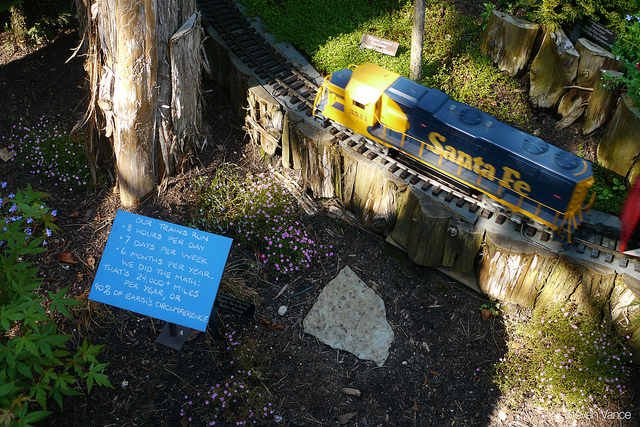Please transcribe the text in this image. Santa Fe OUR TRAINS HOURS EARTH'S PER THAT'S THE YEAR MILES MATH YEAR PER MONTHS 6 DAYS 7 PER week DAY PER 